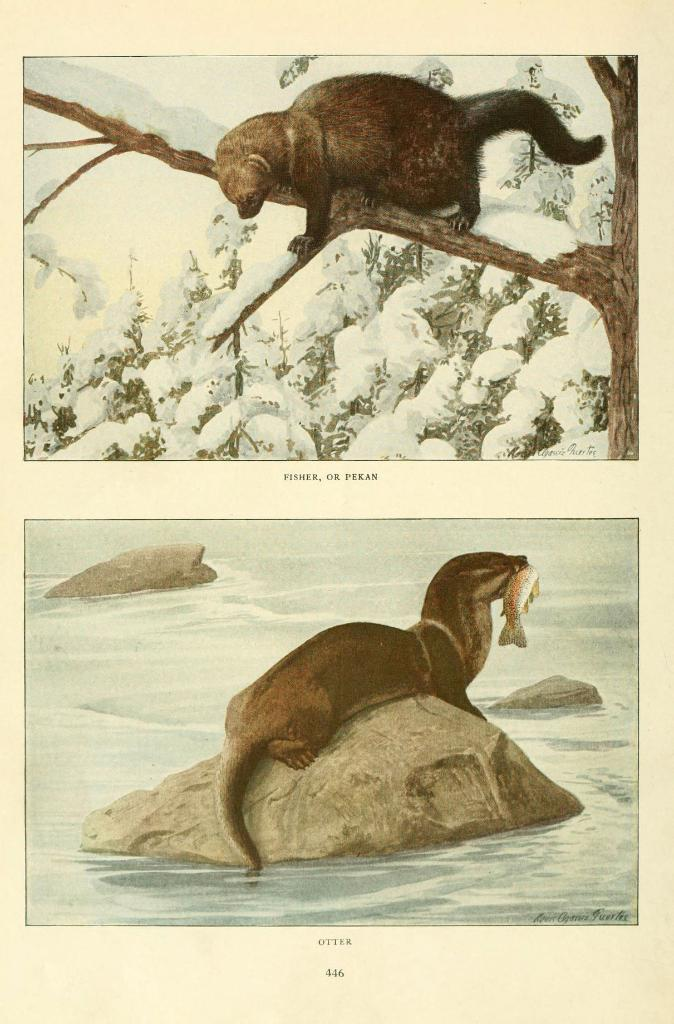What is depicted on the paper in the image? There are pictures of animals on a paper in the image. What type of structure is being discussed in the image? There is no discussion or structure present in the image; it only features pictures of animals on a paper. 